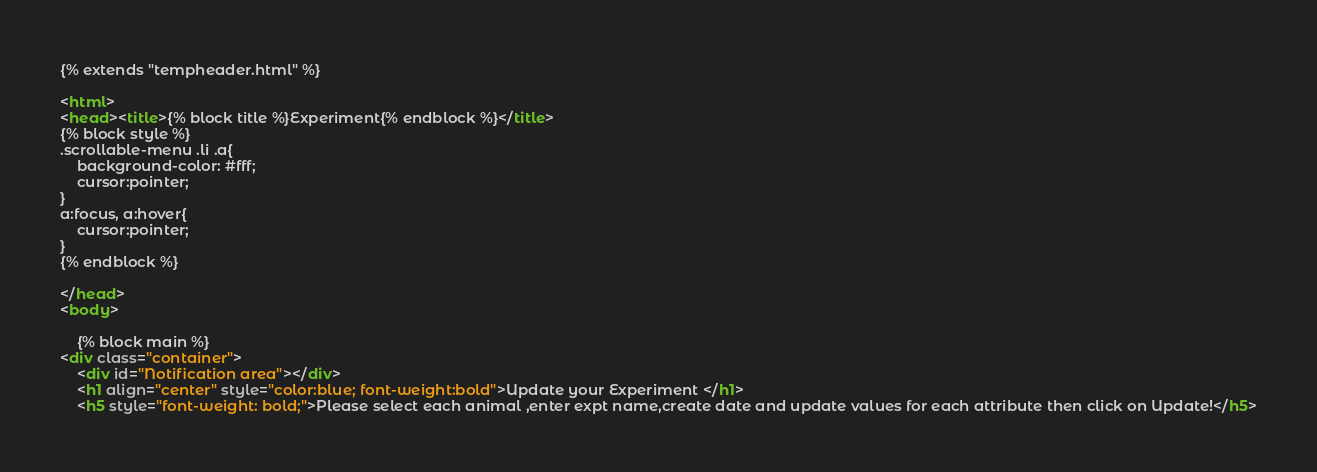Convert code to text. <code><loc_0><loc_0><loc_500><loc_500><_HTML_>{% extends "tempheader.html" %}

<html>
<head><title>{% block title %}Experiment{% endblock %}</title>
{% block style %}
.scrollable-menu .li .a{
	background-color: #fff;
	cursor:pointer;
}
a:focus, a:hover{
    cursor:pointer;
}
{% endblock %}

</head>
<body>

	{% block main %}
<div class="container">
	<div id="Notification area"></div>
    <h1 align="center" style="color:blue; font-weight:bold">Update your Experiment </h1>
	<h5 style="font-weight: bold;">Please select each animal ,enter expt name,create date and update values for each attribute then click on Update!</h5></code> 